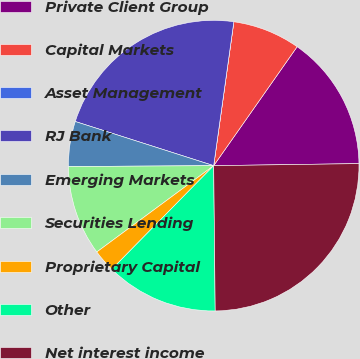<chart> <loc_0><loc_0><loc_500><loc_500><pie_chart><fcel>Private Client Group<fcel>Capital Markets<fcel>Asset Management<fcel>RJ Bank<fcel>Emerging Markets<fcel>Securities Lending<fcel>Proprietary Capital<fcel>Other<fcel>Net interest income<nl><fcel>15.04%<fcel>7.52%<fcel>0.0%<fcel>22.3%<fcel>5.01%<fcel>10.03%<fcel>2.51%<fcel>12.53%<fcel>25.06%<nl></chart> 